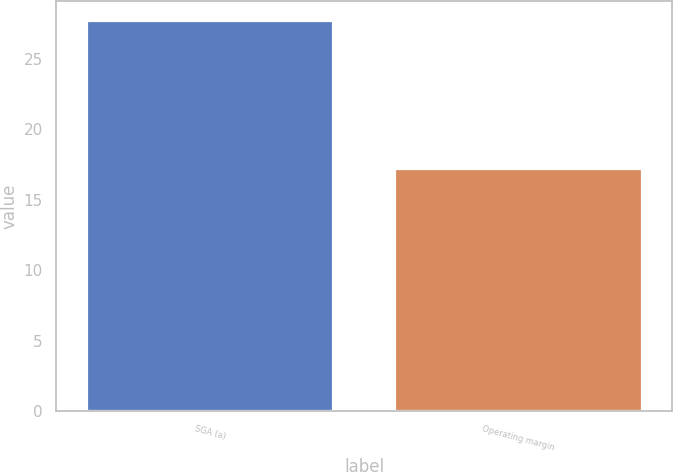Convert chart to OTSL. <chart><loc_0><loc_0><loc_500><loc_500><bar_chart><fcel>SGA (a)<fcel>Operating margin<nl><fcel>27.7<fcel>17.2<nl></chart> 